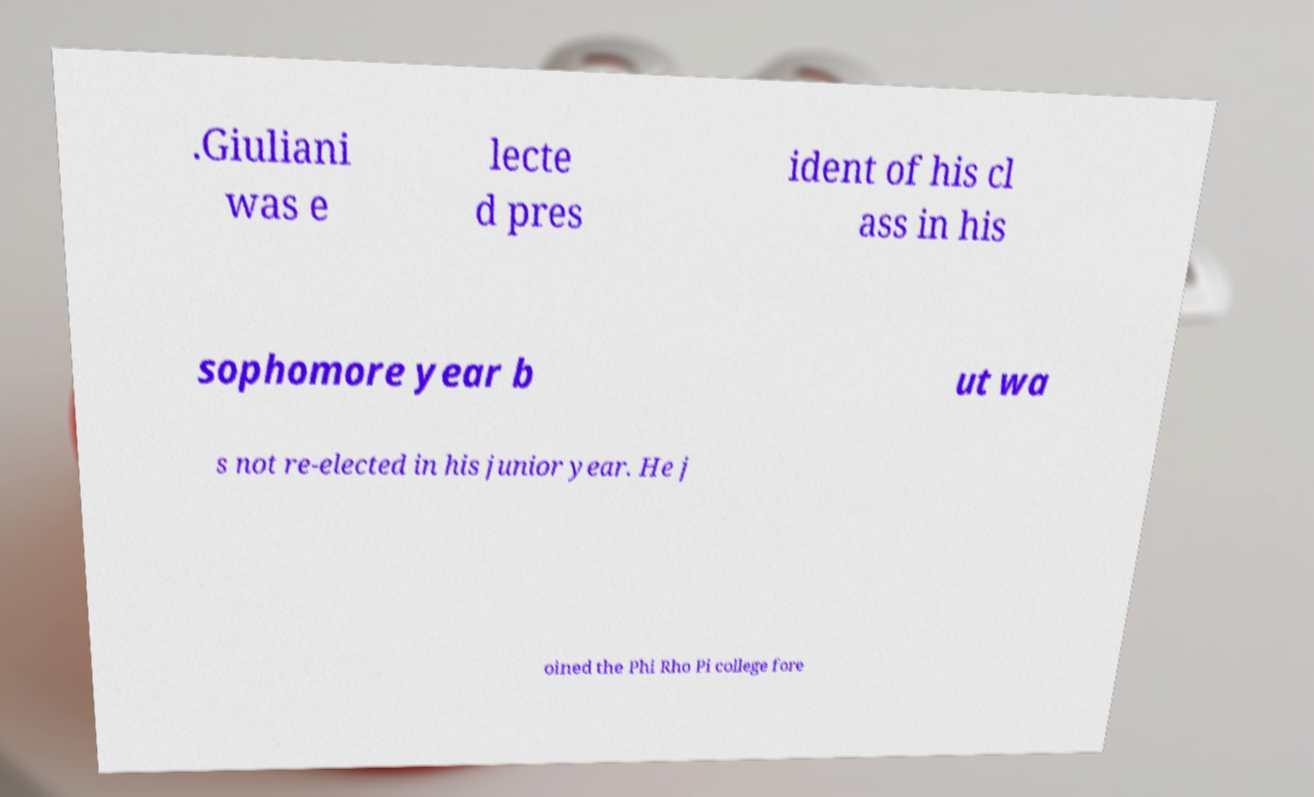Can you read and provide the text displayed in the image?This photo seems to have some interesting text. Can you extract and type it out for me? .Giuliani was e lecte d pres ident of his cl ass in his sophomore year b ut wa s not re-elected in his junior year. He j oined the Phi Rho Pi college fore 